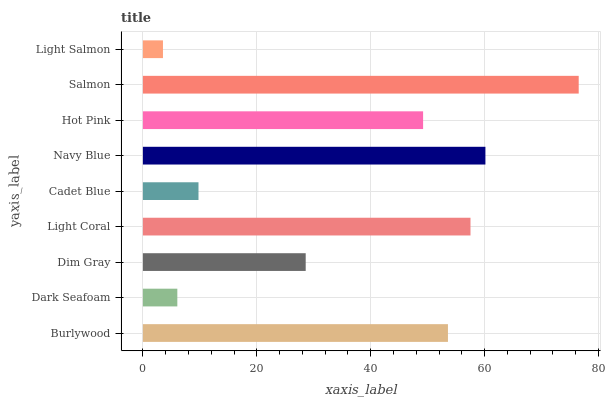Is Light Salmon the minimum?
Answer yes or no. Yes. Is Salmon the maximum?
Answer yes or no. Yes. Is Dark Seafoam the minimum?
Answer yes or no. No. Is Dark Seafoam the maximum?
Answer yes or no. No. Is Burlywood greater than Dark Seafoam?
Answer yes or no. Yes. Is Dark Seafoam less than Burlywood?
Answer yes or no. Yes. Is Dark Seafoam greater than Burlywood?
Answer yes or no. No. Is Burlywood less than Dark Seafoam?
Answer yes or no. No. Is Hot Pink the high median?
Answer yes or no. Yes. Is Hot Pink the low median?
Answer yes or no. Yes. Is Dark Seafoam the high median?
Answer yes or no. No. Is Cadet Blue the low median?
Answer yes or no. No. 